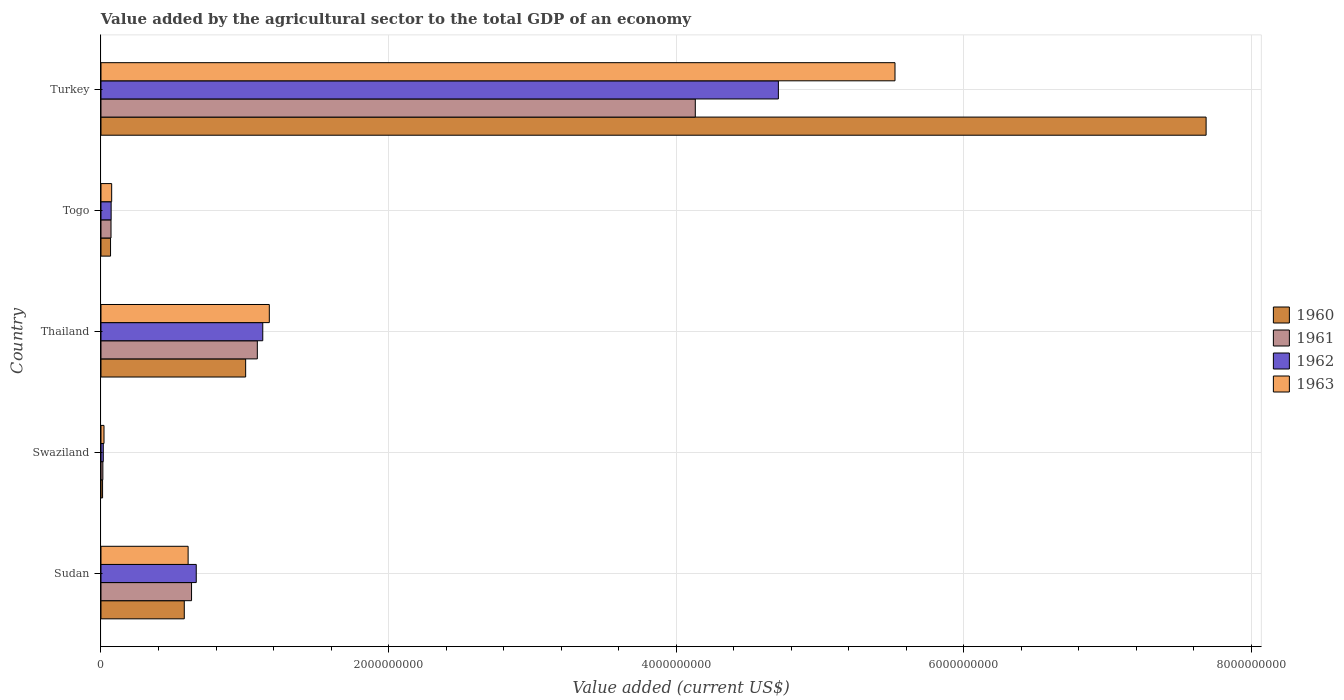How many different coloured bars are there?
Offer a very short reply. 4. Are the number of bars per tick equal to the number of legend labels?
Make the answer very short. Yes. What is the label of the 5th group of bars from the top?
Offer a terse response. Sudan. What is the value added by the agricultural sector to the total GDP in 1962 in Togo?
Offer a very short reply. 7.06e+07. Across all countries, what is the maximum value added by the agricultural sector to the total GDP in 1962?
Your answer should be compact. 4.71e+09. Across all countries, what is the minimum value added by the agricultural sector to the total GDP in 1962?
Keep it short and to the point. 1.60e+07. In which country was the value added by the agricultural sector to the total GDP in 1961 minimum?
Keep it short and to the point. Swaziland. What is the total value added by the agricultural sector to the total GDP in 1960 in the graph?
Make the answer very short. 9.35e+09. What is the difference between the value added by the agricultural sector to the total GDP in 1960 in Swaziland and that in Thailand?
Provide a succinct answer. -9.95e+08. What is the difference between the value added by the agricultural sector to the total GDP in 1963 in Sudan and the value added by the agricultural sector to the total GDP in 1960 in Swaziland?
Your response must be concise. 5.95e+08. What is the average value added by the agricultural sector to the total GDP in 1962 per country?
Your answer should be compact. 1.32e+09. What is the difference between the value added by the agricultural sector to the total GDP in 1963 and value added by the agricultural sector to the total GDP in 1962 in Turkey?
Offer a terse response. 8.11e+08. In how many countries, is the value added by the agricultural sector to the total GDP in 1962 greater than 4400000000 US$?
Your response must be concise. 1. What is the ratio of the value added by the agricultural sector to the total GDP in 1963 in Swaziland to that in Thailand?
Provide a succinct answer. 0.02. Is the difference between the value added by the agricultural sector to the total GDP in 1963 in Sudan and Togo greater than the difference between the value added by the agricultural sector to the total GDP in 1962 in Sudan and Togo?
Ensure brevity in your answer.  No. What is the difference between the highest and the second highest value added by the agricultural sector to the total GDP in 1960?
Ensure brevity in your answer.  6.68e+09. What is the difference between the highest and the lowest value added by the agricultural sector to the total GDP in 1960?
Make the answer very short. 7.67e+09. Is it the case that in every country, the sum of the value added by the agricultural sector to the total GDP in 1961 and value added by the agricultural sector to the total GDP in 1960 is greater than the sum of value added by the agricultural sector to the total GDP in 1962 and value added by the agricultural sector to the total GDP in 1963?
Provide a succinct answer. No. What does the 3rd bar from the top in Sudan represents?
Offer a terse response. 1961. What does the 1st bar from the bottom in Sudan represents?
Your answer should be compact. 1960. Is it the case that in every country, the sum of the value added by the agricultural sector to the total GDP in 1961 and value added by the agricultural sector to the total GDP in 1963 is greater than the value added by the agricultural sector to the total GDP in 1962?
Make the answer very short. Yes. Are all the bars in the graph horizontal?
Provide a succinct answer. Yes. How many countries are there in the graph?
Offer a terse response. 5. Does the graph contain grids?
Provide a short and direct response. Yes. Where does the legend appear in the graph?
Provide a succinct answer. Center right. How many legend labels are there?
Ensure brevity in your answer.  4. What is the title of the graph?
Give a very brief answer. Value added by the agricultural sector to the total GDP of an economy. What is the label or title of the X-axis?
Offer a very short reply. Value added (current US$). What is the Value added (current US$) of 1960 in Sudan?
Keep it short and to the point. 5.79e+08. What is the Value added (current US$) of 1961 in Sudan?
Make the answer very short. 6.30e+08. What is the Value added (current US$) of 1962 in Sudan?
Provide a short and direct response. 6.63e+08. What is the Value added (current US$) in 1963 in Sudan?
Provide a short and direct response. 6.06e+08. What is the Value added (current US$) in 1960 in Swaziland?
Your response must be concise. 1.11e+07. What is the Value added (current US$) in 1961 in Swaziland?
Offer a terse response. 1.30e+07. What is the Value added (current US$) of 1962 in Swaziland?
Ensure brevity in your answer.  1.60e+07. What is the Value added (current US$) in 1963 in Swaziland?
Make the answer very short. 2.10e+07. What is the Value added (current US$) of 1960 in Thailand?
Your response must be concise. 1.01e+09. What is the Value added (current US$) in 1961 in Thailand?
Give a very brief answer. 1.09e+09. What is the Value added (current US$) in 1962 in Thailand?
Your answer should be compact. 1.13e+09. What is the Value added (current US$) of 1963 in Thailand?
Give a very brief answer. 1.17e+09. What is the Value added (current US$) in 1960 in Togo?
Ensure brevity in your answer.  6.65e+07. What is the Value added (current US$) of 1961 in Togo?
Your answer should be very brief. 6.97e+07. What is the Value added (current US$) in 1962 in Togo?
Ensure brevity in your answer.  7.06e+07. What is the Value added (current US$) in 1963 in Togo?
Provide a succinct answer. 7.43e+07. What is the Value added (current US$) of 1960 in Turkey?
Offer a terse response. 7.69e+09. What is the Value added (current US$) in 1961 in Turkey?
Offer a very short reply. 4.13e+09. What is the Value added (current US$) in 1962 in Turkey?
Make the answer very short. 4.71e+09. What is the Value added (current US$) in 1963 in Turkey?
Give a very brief answer. 5.52e+09. Across all countries, what is the maximum Value added (current US$) of 1960?
Keep it short and to the point. 7.69e+09. Across all countries, what is the maximum Value added (current US$) of 1961?
Make the answer very short. 4.13e+09. Across all countries, what is the maximum Value added (current US$) of 1962?
Your response must be concise. 4.71e+09. Across all countries, what is the maximum Value added (current US$) in 1963?
Give a very brief answer. 5.52e+09. Across all countries, what is the minimum Value added (current US$) of 1960?
Offer a terse response. 1.11e+07. Across all countries, what is the minimum Value added (current US$) of 1961?
Offer a terse response. 1.30e+07. Across all countries, what is the minimum Value added (current US$) in 1962?
Offer a very short reply. 1.60e+07. Across all countries, what is the minimum Value added (current US$) in 1963?
Keep it short and to the point. 2.10e+07. What is the total Value added (current US$) of 1960 in the graph?
Your answer should be very brief. 9.35e+09. What is the total Value added (current US$) of 1961 in the graph?
Your answer should be compact. 5.93e+09. What is the total Value added (current US$) in 1962 in the graph?
Ensure brevity in your answer.  6.59e+09. What is the total Value added (current US$) of 1963 in the graph?
Keep it short and to the point. 7.39e+09. What is the difference between the Value added (current US$) of 1960 in Sudan and that in Swaziland?
Your response must be concise. 5.68e+08. What is the difference between the Value added (current US$) of 1961 in Sudan and that in Swaziland?
Ensure brevity in your answer.  6.17e+08. What is the difference between the Value added (current US$) of 1962 in Sudan and that in Swaziland?
Make the answer very short. 6.47e+08. What is the difference between the Value added (current US$) of 1963 in Sudan and that in Swaziland?
Your answer should be compact. 5.85e+08. What is the difference between the Value added (current US$) of 1960 in Sudan and that in Thailand?
Provide a short and direct response. -4.27e+08. What is the difference between the Value added (current US$) of 1961 in Sudan and that in Thailand?
Your answer should be compact. -4.58e+08. What is the difference between the Value added (current US$) in 1962 in Sudan and that in Thailand?
Offer a very short reply. -4.63e+08. What is the difference between the Value added (current US$) of 1963 in Sudan and that in Thailand?
Your answer should be very brief. -5.65e+08. What is the difference between the Value added (current US$) of 1960 in Sudan and that in Togo?
Provide a short and direct response. 5.13e+08. What is the difference between the Value added (current US$) of 1961 in Sudan and that in Togo?
Offer a very short reply. 5.60e+08. What is the difference between the Value added (current US$) in 1962 in Sudan and that in Togo?
Your response must be concise. 5.92e+08. What is the difference between the Value added (current US$) in 1963 in Sudan and that in Togo?
Provide a succinct answer. 5.32e+08. What is the difference between the Value added (current US$) of 1960 in Sudan and that in Turkey?
Make the answer very short. -7.11e+09. What is the difference between the Value added (current US$) of 1961 in Sudan and that in Turkey?
Ensure brevity in your answer.  -3.50e+09. What is the difference between the Value added (current US$) in 1962 in Sudan and that in Turkey?
Provide a short and direct response. -4.05e+09. What is the difference between the Value added (current US$) of 1963 in Sudan and that in Turkey?
Your response must be concise. -4.92e+09. What is the difference between the Value added (current US$) of 1960 in Swaziland and that in Thailand?
Make the answer very short. -9.95e+08. What is the difference between the Value added (current US$) in 1961 in Swaziland and that in Thailand?
Offer a terse response. -1.07e+09. What is the difference between the Value added (current US$) in 1962 in Swaziland and that in Thailand?
Your answer should be very brief. -1.11e+09. What is the difference between the Value added (current US$) of 1963 in Swaziland and that in Thailand?
Give a very brief answer. -1.15e+09. What is the difference between the Value added (current US$) of 1960 in Swaziland and that in Togo?
Your answer should be very brief. -5.54e+07. What is the difference between the Value added (current US$) of 1961 in Swaziland and that in Togo?
Keep it short and to the point. -5.67e+07. What is the difference between the Value added (current US$) in 1962 in Swaziland and that in Togo?
Keep it short and to the point. -5.46e+07. What is the difference between the Value added (current US$) of 1963 in Swaziland and that in Togo?
Make the answer very short. -5.33e+07. What is the difference between the Value added (current US$) of 1960 in Swaziland and that in Turkey?
Give a very brief answer. -7.67e+09. What is the difference between the Value added (current US$) in 1961 in Swaziland and that in Turkey?
Provide a succinct answer. -4.12e+09. What is the difference between the Value added (current US$) of 1962 in Swaziland and that in Turkey?
Keep it short and to the point. -4.70e+09. What is the difference between the Value added (current US$) of 1963 in Swaziland and that in Turkey?
Make the answer very short. -5.50e+09. What is the difference between the Value added (current US$) in 1960 in Thailand and that in Togo?
Your answer should be very brief. 9.40e+08. What is the difference between the Value added (current US$) in 1961 in Thailand and that in Togo?
Give a very brief answer. 1.02e+09. What is the difference between the Value added (current US$) of 1962 in Thailand and that in Togo?
Your answer should be very brief. 1.05e+09. What is the difference between the Value added (current US$) in 1963 in Thailand and that in Togo?
Offer a very short reply. 1.10e+09. What is the difference between the Value added (current US$) in 1960 in Thailand and that in Turkey?
Keep it short and to the point. -6.68e+09. What is the difference between the Value added (current US$) in 1961 in Thailand and that in Turkey?
Make the answer very short. -3.05e+09. What is the difference between the Value added (current US$) in 1962 in Thailand and that in Turkey?
Your answer should be very brief. -3.59e+09. What is the difference between the Value added (current US$) in 1963 in Thailand and that in Turkey?
Provide a succinct answer. -4.35e+09. What is the difference between the Value added (current US$) in 1960 in Togo and that in Turkey?
Make the answer very short. -7.62e+09. What is the difference between the Value added (current US$) of 1961 in Togo and that in Turkey?
Make the answer very short. -4.06e+09. What is the difference between the Value added (current US$) of 1962 in Togo and that in Turkey?
Make the answer very short. -4.64e+09. What is the difference between the Value added (current US$) in 1963 in Togo and that in Turkey?
Make the answer very short. -5.45e+09. What is the difference between the Value added (current US$) of 1960 in Sudan and the Value added (current US$) of 1961 in Swaziland?
Your response must be concise. 5.66e+08. What is the difference between the Value added (current US$) in 1960 in Sudan and the Value added (current US$) in 1962 in Swaziland?
Offer a terse response. 5.63e+08. What is the difference between the Value added (current US$) in 1960 in Sudan and the Value added (current US$) in 1963 in Swaziland?
Your response must be concise. 5.58e+08. What is the difference between the Value added (current US$) of 1961 in Sudan and the Value added (current US$) of 1962 in Swaziland?
Your answer should be compact. 6.14e+08. What is the difference between the Value added (current US$) of 1961 in Sudan and the Value added (current US$) of 1963 in Swaziland?
Your answer should be very brief. 6.09e+08. What is the difference between the Value added (current US$) of 1962 in Sudan and the Value added (current US$) of 1963 in Swaziland?
Provide a short and direct response. 6.42e+08. What is the difference between the Value added (current US$) in 1960 in Sudan and the Value added (current US$) in 1961 in Thailand?
Give a very brief answer. -5.08e+08. What is the difference between the Value added (current US$) in 1960 in Sudan and the Value added (current US$) in 1962 in Thailand?
Ensure brevity in your answer.  -5.46e+08. What is the difference between the Value added (current US$) of 1960 in Sudan and the Value added (current US$) of 1963 in Thailand?
Offer a terse response. -5.91e+08. What is the difference between the Value added (current US$) in 1961 in Sudan and the Value added (current US$) in 1962 in Thailand?
Your response must be concise. -4.95e+08. What is the difference between the Value added (current US$) of 1961 in Sudan and the Value added (current US$) of 1963 in Thailand?
Offer a terse response. -5.41e+08. What is the difference between the Value added (current US$) of 1962 in Sudan and the Value added (current US$) of 1963 in Thailand?
Your answer should be compact. -5.08e+08. What is the difference between the Value added (current US$) in 1960 in Sudan and the Value added (current US$) in 1961 in Togo?
Ensure brevity in your answer.  5.10e+08. What is the difference between the Value added (current US$) in 1960 in Sudan and the Value added (current US$) in 1962 in Togo?
Keep it short and to the point. 5.09e+08. What is the difference between the Value added (current US$) in 1960 in Sudan and the Value added (current US$) in 1963 in Togo?
Provide a succinct answer. 5.05e+08. What is the difference between the Value added (current US$) in 1961 in Sudan and the Value added (current US$) in 1962 in Togo?
Make the answer very short. 5.59e+08. What is the difference between the Value added (current US$) of 1961 in Sudan and the Value added (current US$) of 1963 in Togo?
Your response must be concise. 5.56e+08. What is the difference between the Value added (current US$) in 1962 in Sudan and the Value added (current US$) in 1963 in Togo?
Offer a very short reply. 5.88e+08. What is the difference between the Value added (current US$) of 1960 in Sudan and the Value added (current US$) of 1961 in Turkey?
Keep it short and to the point. -3.55e+09. What is the difference between the Value added (current US$) of 1960 in Sudan and the Value added (current US$) of 1962 in Turkey?
Your answer should be compact. -4.13e+09. What is the difference between the Value added (current US$) in 1960 in Sudan and the Value added (current US$) in 1963 in Turkey?
Your response must be concise. -4.94e+09. What is the difference between the Value added (current US$) of 1961 in Sudan and the Value added (current US$) of 1962 in Turkey?
Make the answer very short. -4.08e+09. What is the difference between the Value added (current US$) of 1961 in Sudan and the Value added (current US$) of 1963 in Turkey?
Make the answer very short. -4.89e+09. What is the difference between the Value added (current US$) in 1962 in Sudan and the Value added (current US$) in 1963 in Turkey?
Offer a very short reply. -4.86e+09. What is the difference between the Value added (current US$) of 1960 in Swaziland and the Value added (current US$) of 1961 in Thailand?
Your response must be concise. -1.08e+09. What is the difference between the Value added (current US$) in 1960 in Swaziland and the Value added (current US$) in 1962 in Thailand?
Offer a very short reply. -1.11e+09. What is the difference between the Value added (current US$) of 1960 in Swaziland and the Value added (current US$) of 1963 in Thailand?
Offer a terse response. -1.16e+09. What is the difference between the Value added (current US$) of 1961 in Swaziland and the Value added (current US$) of 1962 in Thailand?
Your answer should be compact. -1.11e+09. What is the difference between the Value added (current US$) of 1961 in Swaziland and the Value added (current US$) of 1963 in Thailand?
Your response must be concise. -1.16e+09. What is the difference between the Value added (current US$) of 1962 in Swaziland and the Value added (current US$) of 1963 in Thailand?
Ensure brevity in your answer.  -1.15e+09. What is the difference between the Value added (current US$) of 1960 in Swaziland and the Value added (current US$) of 1961 in Togo?
Your answer should be very brief. -5.87e+07. What is the difference between the Value added (current US$) of 1960 in Swaziland and the Value added (current US$) of 1962 in Togo?
Give a very brief answer. -5.95e+07. What is the difference between the Value added (current US$) in 1960 in Swaziland and the Value added (current US$) in 1963 in Togo?
Your response must be concise. -6.32e+07. What is the difference between the Value added (current US$) in 1961 in Swaziland and the Value added (current US$) in 1962 in Togo?
Your answer should be very brief. -5.76e+07. What is the difference between the Value added (current US$) in 1961 in Swaziland and the Value added (current US$) in 1963 in Togo?
Offer a very short reply. -6.13e+07. What is the difference between the Value added (current US$) in 1962 in Swaziland and the Value added (current US$) in 1963 in Togo?
Provide a short and direct response. -5.83e+07. What is the difference between the Value added (current US$) of 1960 in Swaziland and the Value added (current US$) of 1961 in Turkey?
Provide a succinct answer. -4.12e+09. What is the difference between the Value added (current US$) in 1960 in Swaziland and the Value added (current US$) in 1962 in Turkey?
Provide a short and direct response. -4.70e+09. What is the difference between the Value added (current US$) of 1960 in Swaziland and the Value added (current US$) of 1963 in Turkey?
Ensure brevity in your answer.  -5.51e+09. What is the difference between the Value added (current US$) in 1961 in Swaziland and the Value added (current US$) in 1962 in Turkey?
Offer a very short reply. -4.70e+09. What is the difference between the Value added (current US$) in 1961 in Swaziland and the Value added (current US$) in 1963 in Turkey?
Provide a short and direct response. -5.51e+09. What is the difference between the Value added (current US$) of 1962 in Swaziland and the Value added (current US$) of 1963 in Turkey?
Provide a succinct answer. -5.51e+09. What is the difference between the Value added (current US$) of 1960 in Thailand and the Value added (current US$) of 1961 in Togo?
Ensure brevity in your answer.  9.36e+08. What is the difference between the Value added (current US$) in 1960 in Thailand and the Value added (current US$) in 1962 in Togo?
Offer a terse response. 9.36e+08. What is the difference between the Value added (current US$) of 1960 in Thailand and the Value added (current US$) of 1963 in Togo?
Keep it short and to the point. 9.32e+08. What is the difference between the Value added (current US$) of 1961 in Thailand and the Value added (current US$) of 1962 in Togo?
Provide a short and direct response. 1.02e+09. What is the difference between the Value added (current US$) of 1961 in Thailand and the Value added (current US$) of 1963 in Togo?
Your answer should be very brief. 1.01e+09. What is the difference between the Value added (current US$) of 1962 in Thailand and the Value added (current US$) of 1963 in Togo?
Keep it short and to the point. 1.05e+09. What is the difference between the Value added (current US$) of 1960 in Thailand and the Value added (current US$) of 1961 in Turkey?
Offer a terse response. -3.13e+09. What is the difference between the Value added (current US$) of 1960 in Thailand and the Value added (current US$) of 1962 in Turkey?
Make the answer very short. -3.70e+09. What is the difference between the Value added (current US$) of 1960 in Thailand and the Value added (current US$) of 1963 in Turkey?
Provide a succinct answer. -4.52e+09. What is the difference between the Value added (current US$) in 1961 in Thailand and the Value added (current US$) in 1962 in Turkey?
Make the answer very short. -3.62e+09. What is the difference between the Value added (current US$) of 1961 in Thailand and the Value added (current US$) of 1963 in Turkey?
Provide a short and direct response. -4.43e+09. What is the difference between the Value added (current US$) in 1962 in Thailand and the Value added (current US$) in 1963 in Turkey?
Your answer should be very brief. -4.40e+09. What is the difference between the Value added (current US$) of 1960 in Togo and the Value added (current US$) of 1961 in Turkey?
Your response must be concise. -4.07e+09. What is the difference between the Value added (current US$) of 1960 in Togo and the Value added (current US$) of 1962 in Turkey?
Your answer should be compact. -4.64e+09. What is the difference between the Value added (current US$) in 1960 in Togo and the Value added (current US$) in 1963 in Turkey?
Offer a terse response. -5.46e+09. What is the difference between the Value added (current US$) in 1961 in Togo and the Value added (current US$) in 1962 in Turkey?
Make the answer very short. -4.64e+09. What is the difference between the Value added (current US$) of 1961 in Togo and the Value added (current US$) of 1963 in Turkey?
Offer a very short reply. -5.45e+09. What is the difference between the Value added (current US$) of 1962 in Togo and the Value added (current US$) of 1963 in Turkey?
Ensure brevity in your answer.  -5.45e+09. What is the average Value added (current US$) in 1960 per country?
Offer a very short reply. 1.87e+09. What is the average Value added (current US$) in 1961 per country?
Offer a very short reply. 1.19e+09. What is the average Value added (current US$) in 1962 per country?
Your response must be concise. 1.32e+09. What is the average Value added (current US$) in 1963 per country?
Give a very brief answer. 1.48e+09. What is the difference between the Value added (current US$) in 1960 and Value added (current US$) in 1961 in Sudan?
Your response must be concise. -5.05e+07. What is the difference between the Value added (current US$) of 1960 and Value added (current US$) of 1962 in Sudan?
Your answer should be compact. -8.33e+07. What is the difference between the Value added (current US$) of 1960 and Value added (current US$) of 1963 in Sudan?
Provide a short and direct response. -2.67e+07. What is the difference between the Value added (current US$) of 1961 and Value added (current US$) of 1962 in Sudan?
Ensure brevity in your answer.  -3.27e+07. What is the difference between the Value added (current US$) of 1961 and Value added (current US$) of 1963 in Sudan?
Give a very brief answer. 2.38e+07. What is the difference between the Value added (current US$) in 1962 and Value added (current US$) in 1963 in Sudan?
Offer a terse response. 5.66e+07. What is the difference between the Value added (current US$) in 1960 and Value added (current US$) in 1961 in Swaziland?
Provide a succinct answer. -1.96e+06. What is the difference between the Value added (current US$) in 1960 and Value added (current US$) in 1962 in Swaziland?
Provide a succinct answer. -4.90e+06. What is the difference between the Value added (current US$) in 1960 and Value added (current US$) in 1963 in Swaziland?
Your answer should be very brief. -9.94e+06. What is the difference between the Value added (current US$) in 1961 and Value added (current US$) in 1962 in Swaziland?
Provide a succinct answer. -2.94e+06. What is the difference between the Value added (current US$) of 1961 and Value added (current US$) of 1963 in Swaziland?
Give a very brief answer. -7.98e+06. What is the difference between the Value added (current US$) of 1962 and Value added (current US$) of 1963 in Swaziland?
Your response must be concise. -5.04e+06. What is the difference between the Value added (current US$) in 1960 and Value added (current US$) in 1961 in Thailand?
Provide a succinct answer. -8.12e+07. What is the difference between the Value added (current US$) in 1960 and Value added (current US$) in 1962 in Thailand?
Your answer should be very brief. -1.19e+08. What is the difference between the Value added (current US$) in 1960 and Value added (current US$) in 1963 in Thailand?
Your answer should be compact. -1.65e+08. What is the difference between the Value added (current US$) of 1961 and Value added (current US$) of 1962 in Thailand?
Give a very brief answer. -3.78e+07. What is the difference between the Value added (current US$) in 1961 and Value added (current US$) in 1963 in Thailand?
Make the answer very short. -8.33e+07. What is the difference between the Value added (current US$) of 1962 and Value added (current US$) of 1963 in Thailand?
Give a very brief answer. -4.55e+07. What is the difference between the Value added (current US$) in 1960 and Value added (current US$) in 1961 in Togo?
Your response must be concise. -3.24e+06. What is the difference between the Value added (current US$) in 1960 and Value added (current US$) in 1962 in Togo?
Give a very brief answer. -4.13e+06. What is the difference between the Value added (current US$) in 1960 and Value added (current US$) in 1963 in Togo?
Your answer should be compact. -7.80e+06. What is the difference between the Value added (current US$) of 1961 and Value added (current US$) of 1962 in Togo?
Your answer should be compact. -8.86e+05. What is the difference between the Value added (current US$) in 1961 and Value added (current US$) in 1963 in Togo?
Your answer should be very brief. -4.56e+06. What is the difference between the Value added (current US$) in 1962 and Value added (current US$) in 1963 in Togo?
Give a very brief answer. -3.67e+06. What is the difference between the Value added (current US$) of 1960 and Value added (current US$) of 1961 in Turkey?
Your answer should be compact. 3.55e+09. What is the difference between the Value added (current US$) of 1960 and Value added (current US$) of 1962 in Turkey?
Offer a terse response. 2.97e+09. What is the difference between the Value added (current US$) of 1960 and Value added (current US$) of 1963 in Turkey?
Offer a terse response. 2.16e+09. What is the difference between the Value added (current US$) in 1961 and Value added (current US$) in 1962 in Turkey?
Make the answer very short. -5.78e+08. What is the difference between the Value added (current US$) of 1961 and Value added (current US$) of 1963 in Turkey?
Ensure brevity in your answer.  -1.39e+09. What is the difference between the Value added (current US$) in 1962 and Value added (current US$) in 1963 in Turkey?
Provide a short and direct response. -8.11e+08. What is the ratio of the Value added (current US$) of 1960 in Sudan to that in Swaziland?
Provide a succinct answer. 52.37. What is the ratio of the Value added (current US$) in 1961 in Sudan to that in Swaziland?
Your answer should be very brief. 48.37. What is the ratio of the Value added (current US$) in 1962 in Sudan to that in Swaziland?
Your answer should be compact. 41.51. What is the ratio of the Value added (current US$) of 1963 in Sudan to that in Swaziland?
Keep it short and to the point. 28.86. What is the ratio of the Value added (current US$) in 1960 in Sudan to that in Thailand?
Ensure brevity in your answer.  0.58. What is the ratio of the Value added (current US$) of 1961 in Sudan to that in Thailand?
Make the answer very short. 0.58. What is the ratio of the Value added (current US$) of 1962 in Sudan to that in Thailand?
Give a very brief answer. 0.59. What is the ratio of the Value added (current US$) of 1963 in Sudan to that in Thailand?
Your answer should be compact. 0.52. What is the ratio of the Value added (current US$) in 1960 in Sudan to that in Togo?
Keep it short and to the point. 8.71. What is the ratio of the Value added (current US$) of 1961 in Sudan to that in Togo?
Give a very brief answer. 9.03. What is the ratio of the Value added (current US$) in 1962 in Sudan to that in Togo?
Ensure brevity in your answer.  9.38. What is the ratio of the Value added (current US$) in 1963 in Sudan to that in Togo?
Offer a terse response. 8.16. What is the ratio of the Value added (current US$) of 1960 in Sudan to that in Turkey?
Give a very brief answer. 0.08. What is the ratio of the Value added (current US$) of 1961 in Sudan to that in Turkey?
Offer a very short reply. 0.15. What is the ratio of the Value added (current US$) of 1962 in Sudan to that in Turkey?
Provide a succinct answer. 0.14. What is the ratio of the Value added (current US$) of 1963 in Sudan to that in Turkey?
Give a very brief answer. 0.11. What is the ratio of the Value added (current US$) of 1960 in Swaziland to that in Thailand?
Offer a very short reply. 0.01. What is the ratio of the Value added (current US$) of 1961 in Swaziland to that in Thailand?
Ensure brevity in your answer.  0.01. What is the ratio of the Value added (current US$) in 1962 in Swaziland to that in Thailand?
Ensure brevity in your answer.  0.01. What is the ratio of the Value added (current US$) in 1963 in Swaziland to that in Thailand?
Ensure brevity in your answer.  0.02. What is the ratio of the Value added (current US$) of 1960 in Swaziland to that in Togo?
Give a very brief answer. 0.17. What is the ratio of the Value added (current US$) of 1961 in Swaziland to that in Togo?
Ensure brevity in your answer.  0.19. What is the ratio of the Value added (current US$) in 1962 in Swaziland to that in Togo?
Ensure brevity in your answer.  0.23. What is the ratio of the Value added (current US$) of 1963 in Swaziland to that in Togo?
Your response must be concise. 0.28. What is the ratio of the Value added (current US$) in 1960 in Swaziland to that in Turkey?
Keep it short and to the point. 0. What is the ratio of the Value added (current US$) in 1961 in Swaziland to that in Turkey?
Provide a short and direct response. 0. What is the ratio of the Value added (current US$) of 1962 in Swaziland to that in Turkey?
Your answer should be very brief. 0. What is the ratio of the Value added (current US$) in 1963 in Swaziland to that in Turkey?
Your answer should be very brief. 0. What is the ratio of the Value added (current US$) in 1960 in Thailand to that in Togo?
Provide a succinct answer. 15.13. What is the ratio of the Value added (current US$) of 1961 in Thailand to that in Togo?
Your response must be concise. 15.6. What is the ratio of the Value added (current US$) in 1962 in Thailand to that in Togo?
Your answer should be very brief. 15.93. What is the ratio of the Value added (current US$) in 1963 in Thailand to that in Togo?
Your answer should be very brief. 15.76. What is the ratio of the Value added (current US$) in 1960 in Thailand to that in Turkey?
Your answer should be compact. 0.13. What is the ratio of the Value added (current US$) of 1961 in Thailand to that in Turkey?
Your answer should be compact. 0.26. What is the ratio of the Value added (current US$) in 1962 in Thailand to that in Turkey?
Provide a succinct answer. 0.24. What is the ratio of the Value added (current US$) in 1963 in Thailand to that in Turkey?
Give a very brief answer. 0.21. What is the ratio of the Value added (current US$) of 1960 in Togo to that in Turkey?
Your answer should be very brief. 0.01. What is the ratio of the Value added (current US$) in 1961 in Togo to that in Turkey?
Ensure brevity in your answer.  0.02. What is the ratio of the Value added (current US$) in 1962 in Togo to that in Turkey?
Provide a short and direct response. 0.01. What is the ratio of the Value added (current US$) of 1963 in Togo to that in Turkey?
Provide a short and direct response. 0.01. What is the difference between the highest and the second highest Value added (current US$) in 1960?
Provide a succinct answer. 6.68e+09. What is the difference between the highest and the second highest Value added (current US$) in 1961?
Your response must be concise. 3.05e+09. What is the difference between the highest and the second highest Value added (current US$) of 1962?
Your response must be concise. 3.59e+09. What is the difference between the highest and the second highest Value added (current US$) in 1963?
Offer a very short reply. 4.35e+09. What is the difference between the highest and the lowest Value added (current US$) in 1960?
Make the answer very short. 7.67e+09. What is the difference between the highest and the lowest Value added (current US$) in 1961?
Your response must be concise. 4.12e+09. What is the difference between the highest and the lowest Value added (current US$) in 1962?
Provide a succinct answer. 4.70e+09. What is the difference between the highest and the lowest Value added (current US$) in 1963?
Provide a succinct answer. 5.50e+09. 